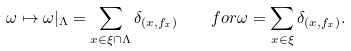Convert formula to latex. <formula><loc_0><loc_0><loc_500><loc_500>\omega \mapsto \omega | _ { \Lambda } = \sum _ { x \in \xi \cap \Lambda } \delta _ { ( x , f _ { x } ) } \quad f o r \omega = \sum _ { x \in \xi } \delta _ { ( x , f _ { x } ) } .</formula> 